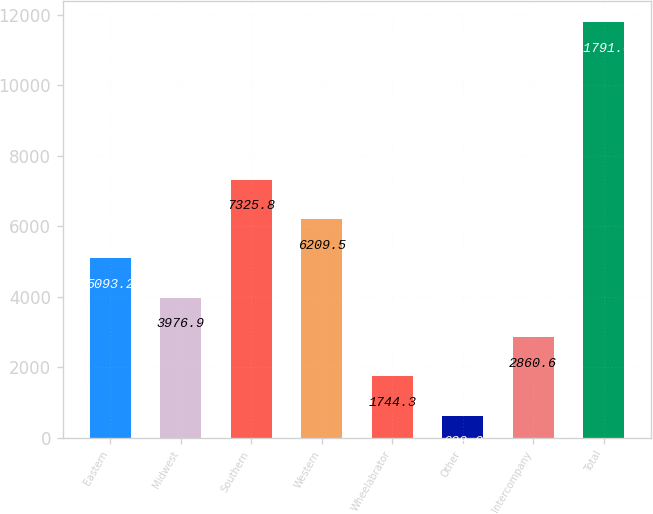Convert chart. <chart><loc_0><loc_0><loc_500><loc_500><bar_chart><fcel>Eastern<fcel>Midwest<fcel>Southern<fcel>Western<fcel>Wheelabrator<fcel>Other<fcel>Intercompany<fcel>Total<nl><fcel>5093.2<fcel>3976.9<fcel>7325.8<fcel>6209.5<fcel>1744.3<fcel>628<fcel>2860.6<fcel>11791<nl></chart> 